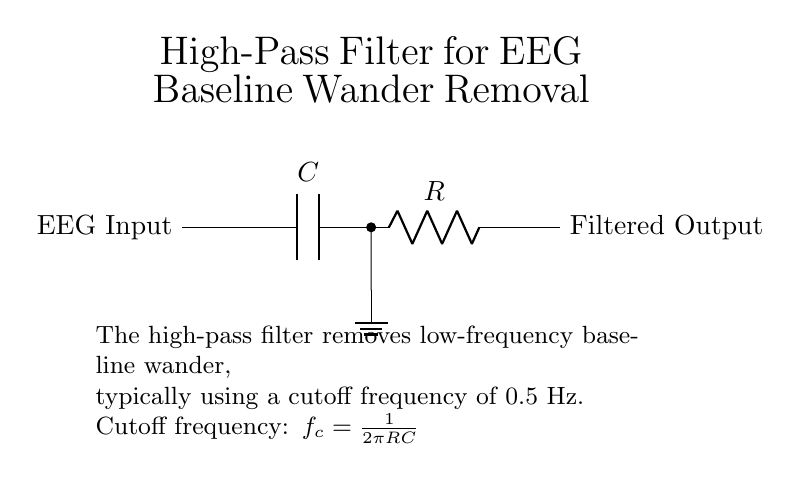What is the function of the circuit? The circuit functions as a high-pass filter, which is designed to remove low-frequency signals (specifically, baseline wander) from the EEG recordings.
Answer: High-pass filter What components are included in the circuit? The components present in the circuit are a capacitor (C) and a resistor (R) connected in series. These components work together to create the filtering effect.
Answer: Capacitor and resistor What is the cutoff frequency formula for this filter? The cutoff frequency is calculated using the formula f_c = 1/(2πRC), where R is the resistance and C is the capacitance. This formula defines the frequency at which the filter starts to attenuate the input signal.
Answer: 1/(2πRC) What is the location of the ground in the circuit? The ground is connected to the junction between the capacitor (C) and the resistor (R). It provides a reference point for the voltage levels in the circuit and allows the circuit to complete its pathway.
Answer: Between capacitor and resistor What type of signal is being filtered by this circuit? The circuit is specifically filtering out low-frequency signals, which in this context refers to the baseline wander present in electroencephalogram (EEG) recordings. This helps enhance the clarity of the EEG signal.
Answer: Low-frequency signals What happens to signals below the cutoff frequency? Signals that are below the cutoff frequency are greatly attenuated, meaning they lose strength and are minimized in the output. This reduces unwanted fluctuations in the EEG signal due to baseline wander.
Answer: They are attenuated 